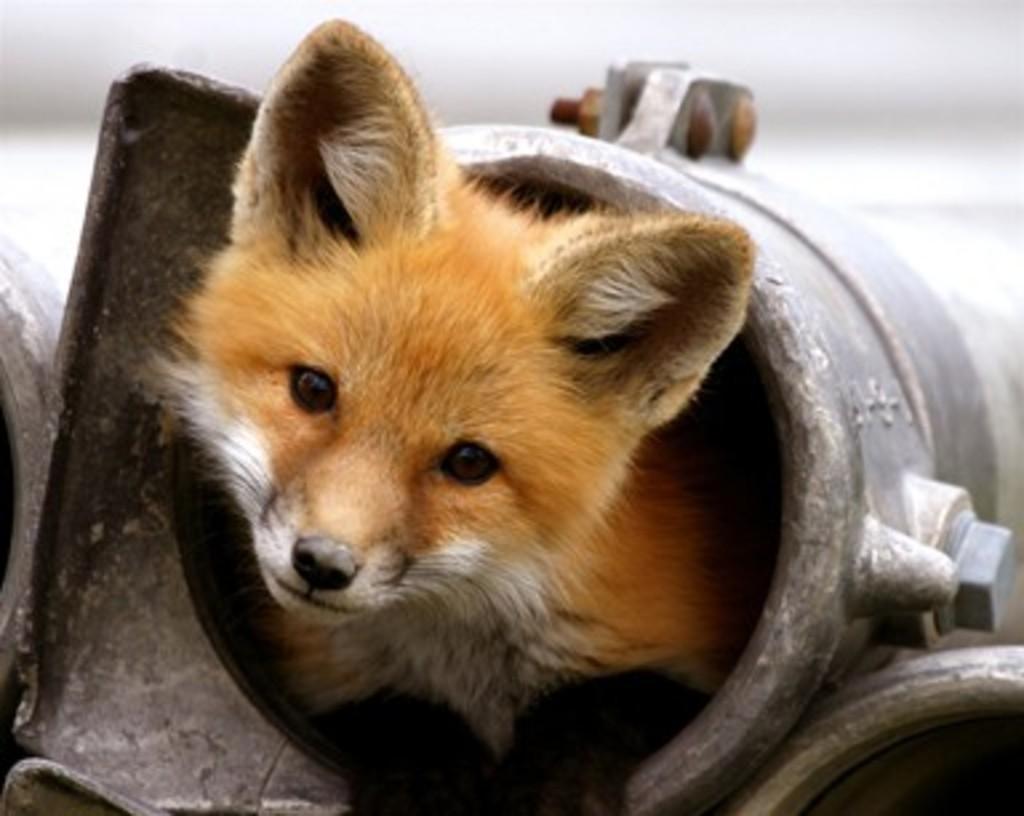How would you summarize this image in a sentence or two? In this picture we can see an animal in a metal object and in the background we can see it is blurry. 